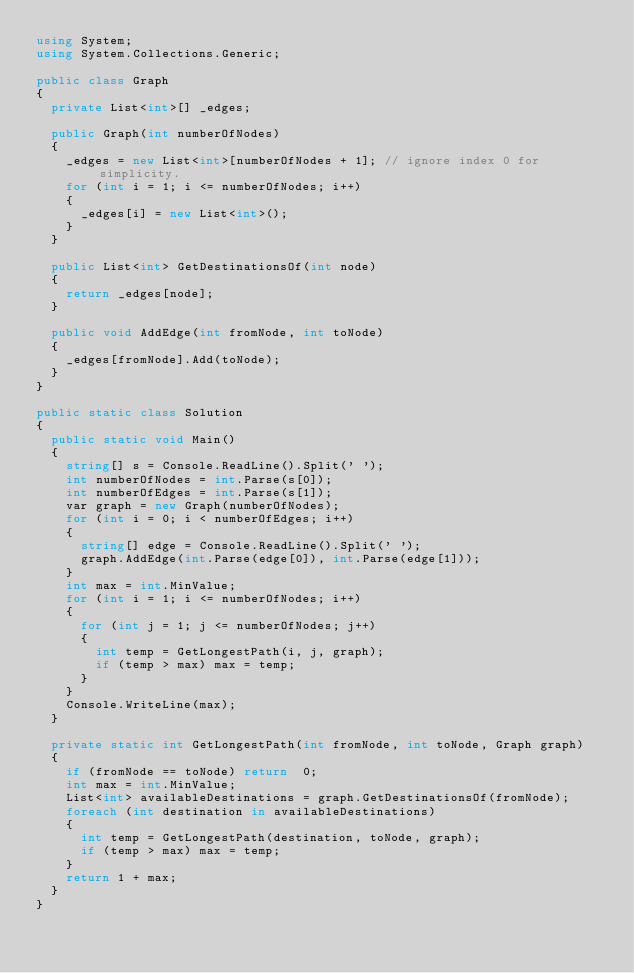<code> <loc_0><loc_0><loc_500><loc_500><_C#_>using System;
using System.Collections.Generic;

public class Graph
{
  private List<int>[] _edges;

  public Graph(int numberOfNodes)
  {
    _edges = new List<int>[numberOfNodes + 1]; // ignore index 0 for simplicity.
    for (int i = 1; i <= numberOfNodes; i++)
    {
      _edges[i] = new List<int>();
    }
  }

  public List<int> GetDestinationsOf(int node)
  {
    return _edges[node];
  }

  public void AddEdge(int fromNode, int toNode)
  {
    _edges[fromNode].Add(toNode);
  }
}

public static class Solution
{
  public static void Main()
  {
    string[] s = Console.ReadLine().Split(' ');
    int numberOfNodes = int.Parse(s[0]);
    int numberOfEdges = int.Parse(s[1]);
    var graph = new Graph(numberOfNodes);
    for (int i = 0; i < numberOfEdges; i++)
    {
      string[] edge = Console.ReadLine().Split(' ');
      graph.AddEdge(int.Parse(edge[0]), int.Parse(edge[1]));
    }
    int max = int.MinValue;
    for (int i = 1; i <= numberOfNodes; i++)
    {
      for (int j = 1; j <= numberOfNodes; j++)
      {
        int temp = GetLongestPath(i, j, graph);
        if (temp > max) max = temp;
      }
    }
    Console.WriteLine(max);
  }

  private static int GetLongestPath(int fromNode, int toNode, Graph graph)
  {
    if (fromNode == toNode) return  0;
    int max = int.MinValue;
    List<int> availableDestinations = graph.GetDestinationsOf(fromNode);
    foreach (int destination in availableDestinations)
    {
      int temp = GetLongestPath(destination, toNode, graph);
      if (temp > max) max = temp;
    }
    return 1 + max;
  }
}</code> 